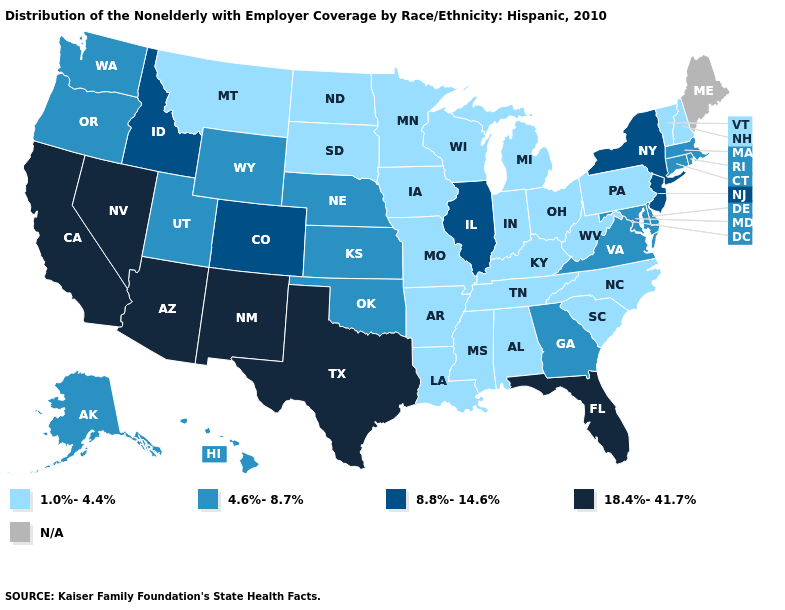Which states hav the highest value in the MidWest?
Give a very brief answer. Illinois. Name the states that have a value in the range 4.6%-8.7%?
Write a very short answer. Alaska, Connecticut, Delaware, Georgia, Hawaii, Kansas, Maryland, Massachusetts, Nebraska, Oklahoma, Oregon, Rhode Island, Utah, Virginia, Washington, Wyoming. Name the states that have a value in the range 4.6%-8.7%?
Keep it brief. Alaska, Connecticut, Delaware, Georgia, Hawaii, Kansas, Maryland, Massachusetts, Nebraska, Oklahoma, Oregon, Rhode Island, Utah, Virginia, Washington, Wyoming. What is the value of Arkansas?
Be succinct. 1.0%-4.4%. Name the states that have a value in the range 18.4%-41.7%?
Be succinct. Arizona, California, Florida, Nevada, New Mexico, Texas. Does New Hampshire have the lowest value in the Northeast?
Keep it brief. Yes. Name the states that have a value in the range 8.8%-14.6%?
Answer briefly. Colorado, Idaho, Illinois, New Jersey, New York. Name the states that have a value in the range 8.8%-14.6%?
Short answer required. Colorado, Idaho, Illinois, New Jersey, New York. Name the states that have a value in the range 8.8%-14.6%?
Write a very short answer. Colorado, Idaho, Illinois, New Jersey, New York. Among the states that border Utah , which have the lowest value?
Quick response, please. Wyoming. Which states have the lowest value in the South?
Write a very short answer. Alabama, Arkansas, Kentucky, Louisiana, Mississippi, North Carolina, South Carolina, Tennessee, West Virginia. Does the first symbol in the legend represent the smallest category?
Short answer required. Yes. What is the value of New Mexico?
Give a very brief answer. 18.4%-41.7%. What is the highest value in the USA?
Quick response, please. 18.4%-41.7%. Name the states that have a value in the range 18.4%-41.7%?
Quick response, please. Arizona, California, Florida, Nevada, New Mexico, Texas. 